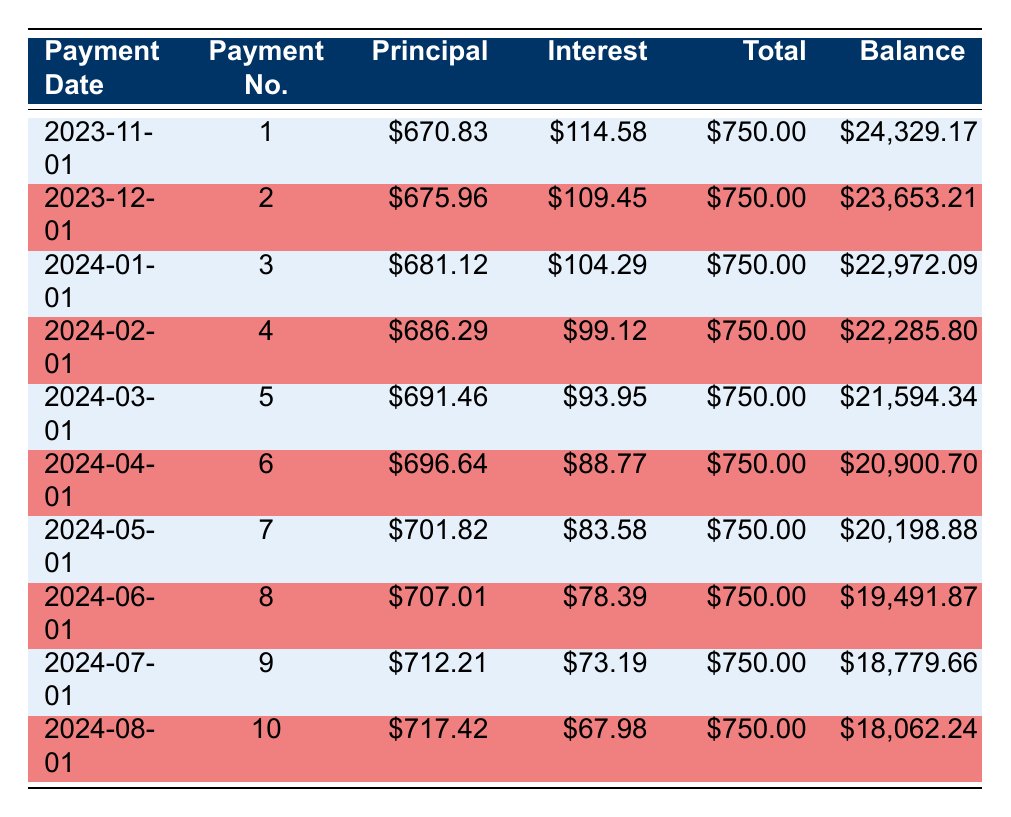What is the remaining balance after the third payment? To find the remaining balance after the third payment, we look at the row for payment number 3. The remaining balance is listed as 22972.09.
Answer: 22972.09 How much interest was paid in the second payment? In the table, the interest payment for payment number 2 is clearly indicated as 109.45.
Answer: 109.45 True or False: The total payment amount remains constant throughout the payments. The table shows each payment amount under the total payment column, and they are all listed as 750.00, indicating that it does remain constant.
Answer: True What is the total principal paid after the first four payments? We need to sum the principal payments for the first four payments: 670.83 + 675.96 + 681.12 + 686.29 = 2994.20. So the total principal paid after four payments is 2994.20.
Answer: 2994.20 What is the average interest payment for the first ten payments? First, sum each of the interest payments from the first ten payments: 114.58 + 109.45 + 104.29 + 99.12 + 93.95 + 88.77 + 83.58 + 78.39 + 73.19 + 67.98 =  1032.30. Next, divide by the number of payments (10). Thus, the average interest payment is 1032.30 / 10 = 103.23.
Answer: 103.23 How much is the principal payment for payment number 5? The row for payment number 5 shows the principal payment as 691.46, which is directly listed.
Answer: 691.46 What is the total amount paid towards the loan after six payments? To find the total amount paid after six payments, we multiply the monthly payment of 750.00 by 6, which gives us 4500.00.
Answer: 4500.00 Which payment has the highest principal payment and what is that amount? By examining the principal payment column, the highest principal payment is found in payment number 7, which is recorded as 701.82.
Answer: 701.82 True or False: The interest payment decreases with each successive payment. Observing the interest payments from the table shows that they are decreasing in value, confirming this statement is true.
Answer: True 